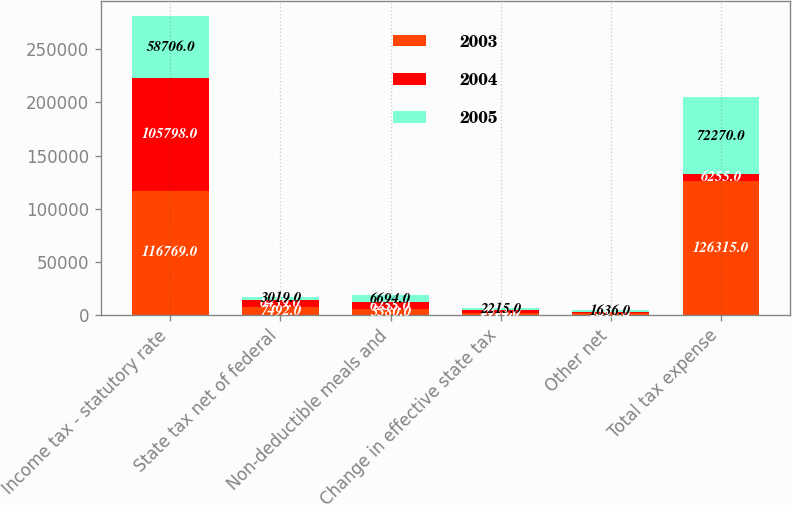<chart> <loc_0><loc_0><loc_500><loc_500><stacked_bar_chart><ecel><fcel>Income tax - statutory rate<fcel>State tax net of federal<fcel>Non-deductible meals and<fcel>Change in effective state tax<fcel>Other net<fcel>Total tax expense<nl><fcel>2003<fcel>116769<fcel>7492<fcel>5380<fcel>1914<fcel>1412<fcel>126315<nl><fcel>2004<fcel>105798<fcel>6439<fcel>6255<fcel>2622<fcel>1309<fcel>6255<nl><fcel>2005<fcel>58706<fcel>3019<fcel>6694<fcel>2215<fcel>1636<fcel>72270<nl></chart> 